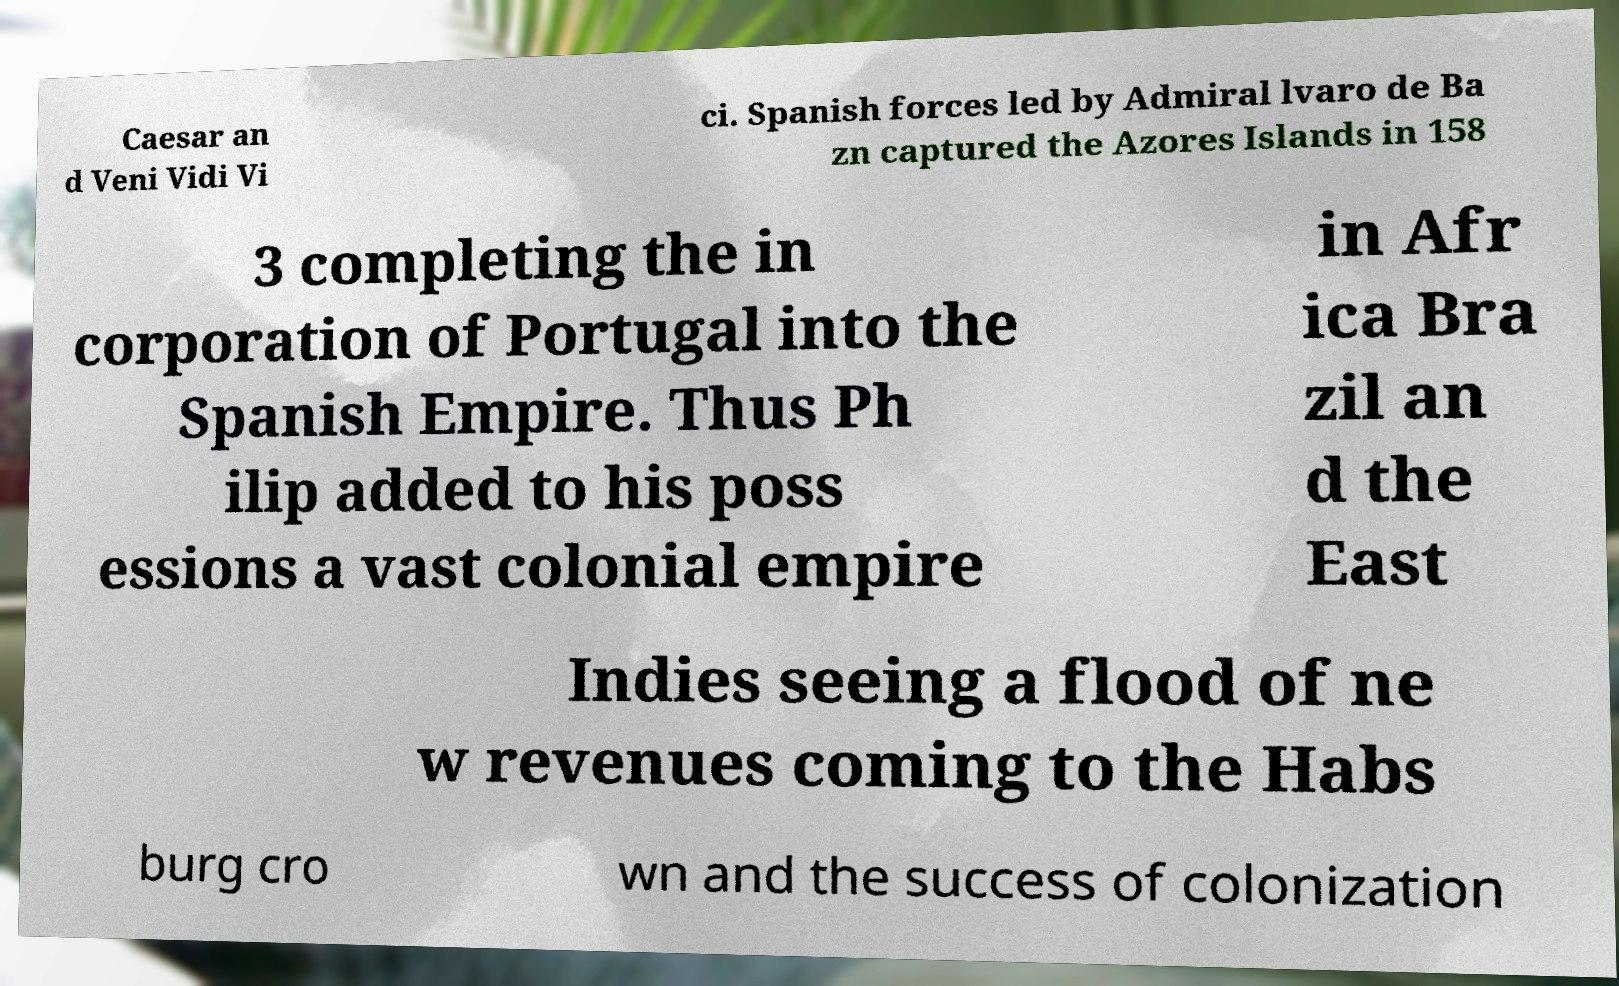Could you extract and type out the text from this image? Caesar an d Veni Vidi Vi ci. Spanish forces led by Admiral lvaro de Ba zn captured the Azores Islands in 158 3 completing the in corporation of Portugal into the Spanish Empire. Thus Ph ilip added to his poss essions a vast colonial empire in Afr ica Bra zil an d the East Indies seeing a flood of ne w revenues coming to the Habs burg cro wn and the success of colonization 